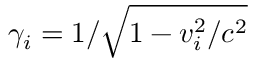Convert formula to latex. <formula><loc_0><loc_0><loc_500><loc_500>\gamma _ { i } = 1 / \sqrt { 1 - v _ { i } ^ { 2 } / c ^ { 2 } }</formula> 